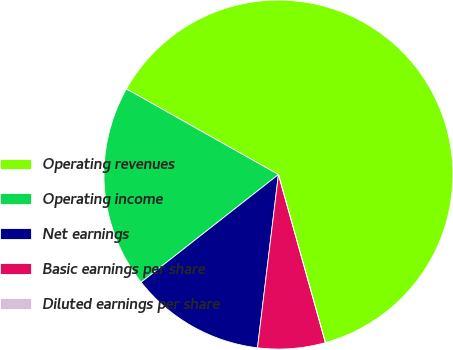Convert chart to OTSL. <chart><loc_0><loc_0><loc_500><loc_500><pie_chart><fcel>Operating revenues<fcel>Operating income<fcel>Net earnings<fcel>Basic earnings per share<fcel>Diluted earnings per share<nl><fcel>62.5%<fcel>18.75%<fcel>12.5%<fcel>6.25%<fcel>0.0%<nl></chart> 